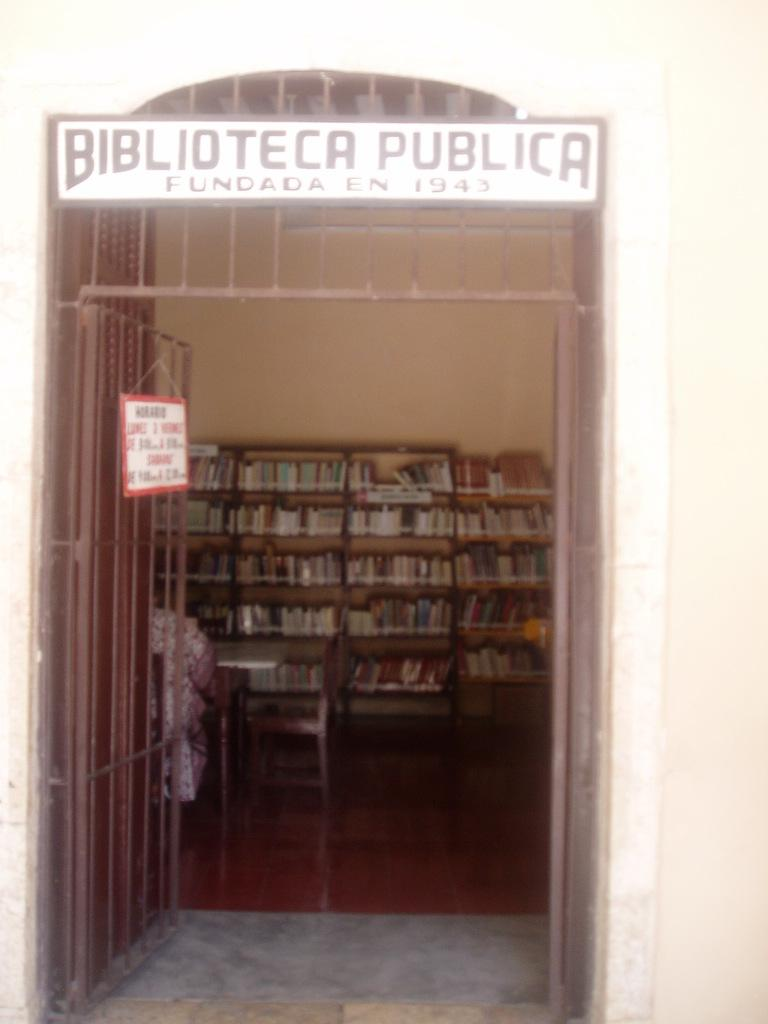<image>
Summarize the visual content of the image. The entrance to a library has a sign above the door that reads Biblioteca Publica Fundada En 1943. 